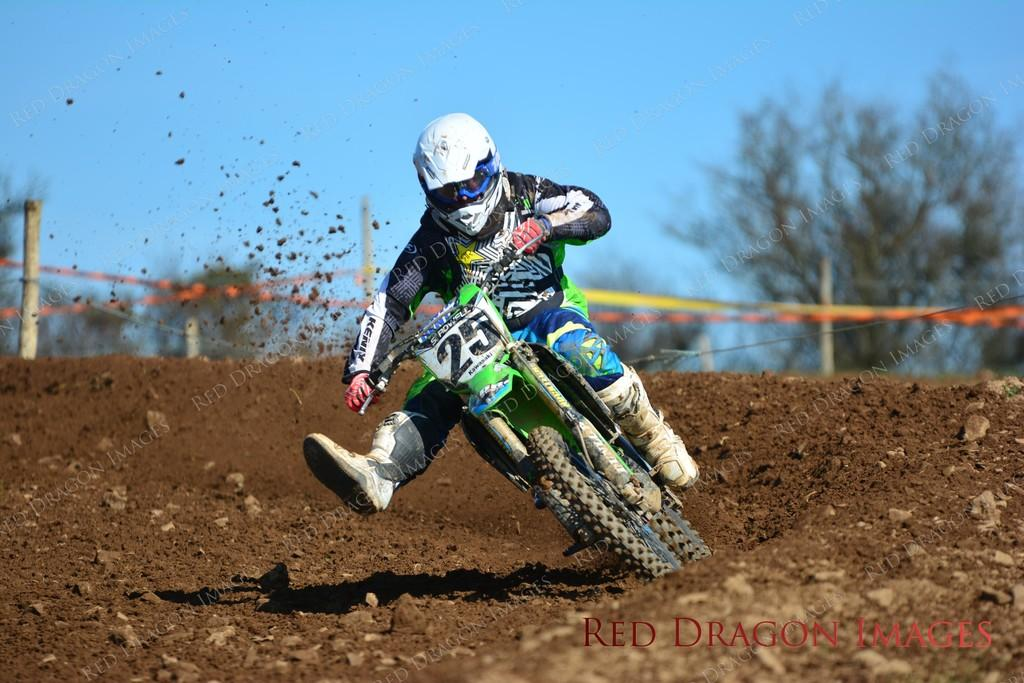<image>
Create a compact narrative representing the image presented. Man wearing a helmet and riding a motorbike with the number 25 on it. 